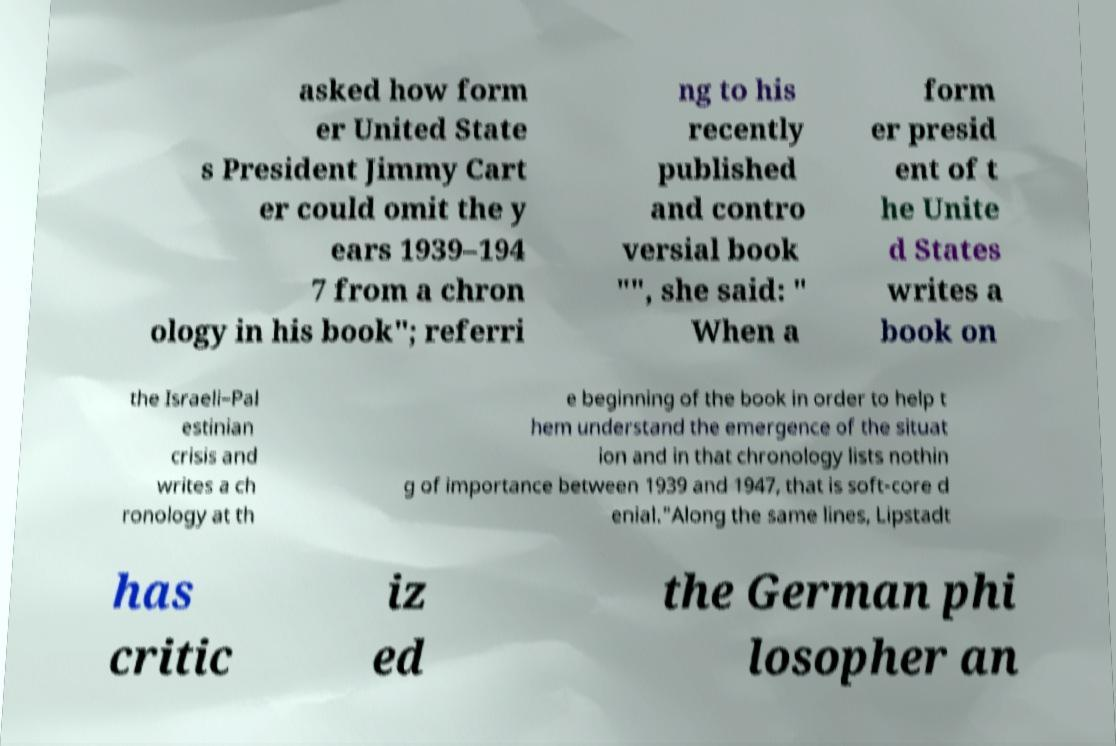What messages or text are displayed in this image? I need them in a readable, typed format. asked how form er United State s President Jimmy Cart er could omit the y ears 1939–194 7 from a chron ology in his book"; referri ng to his recently published and contro versial book "", she said: " When a form er presid ent of t he Unite d States writes a book on the Israeli–Pal estinian crisis and writes a ch ronology at th e beginning of the book in order to help t hem understand the emergence of the situat ion and in that chronology lists nothin g of importance between 1939 and 1947, that is soft-core d enial."Along the same lines, Lipstadt has critic iz ed the German phi losopher an 